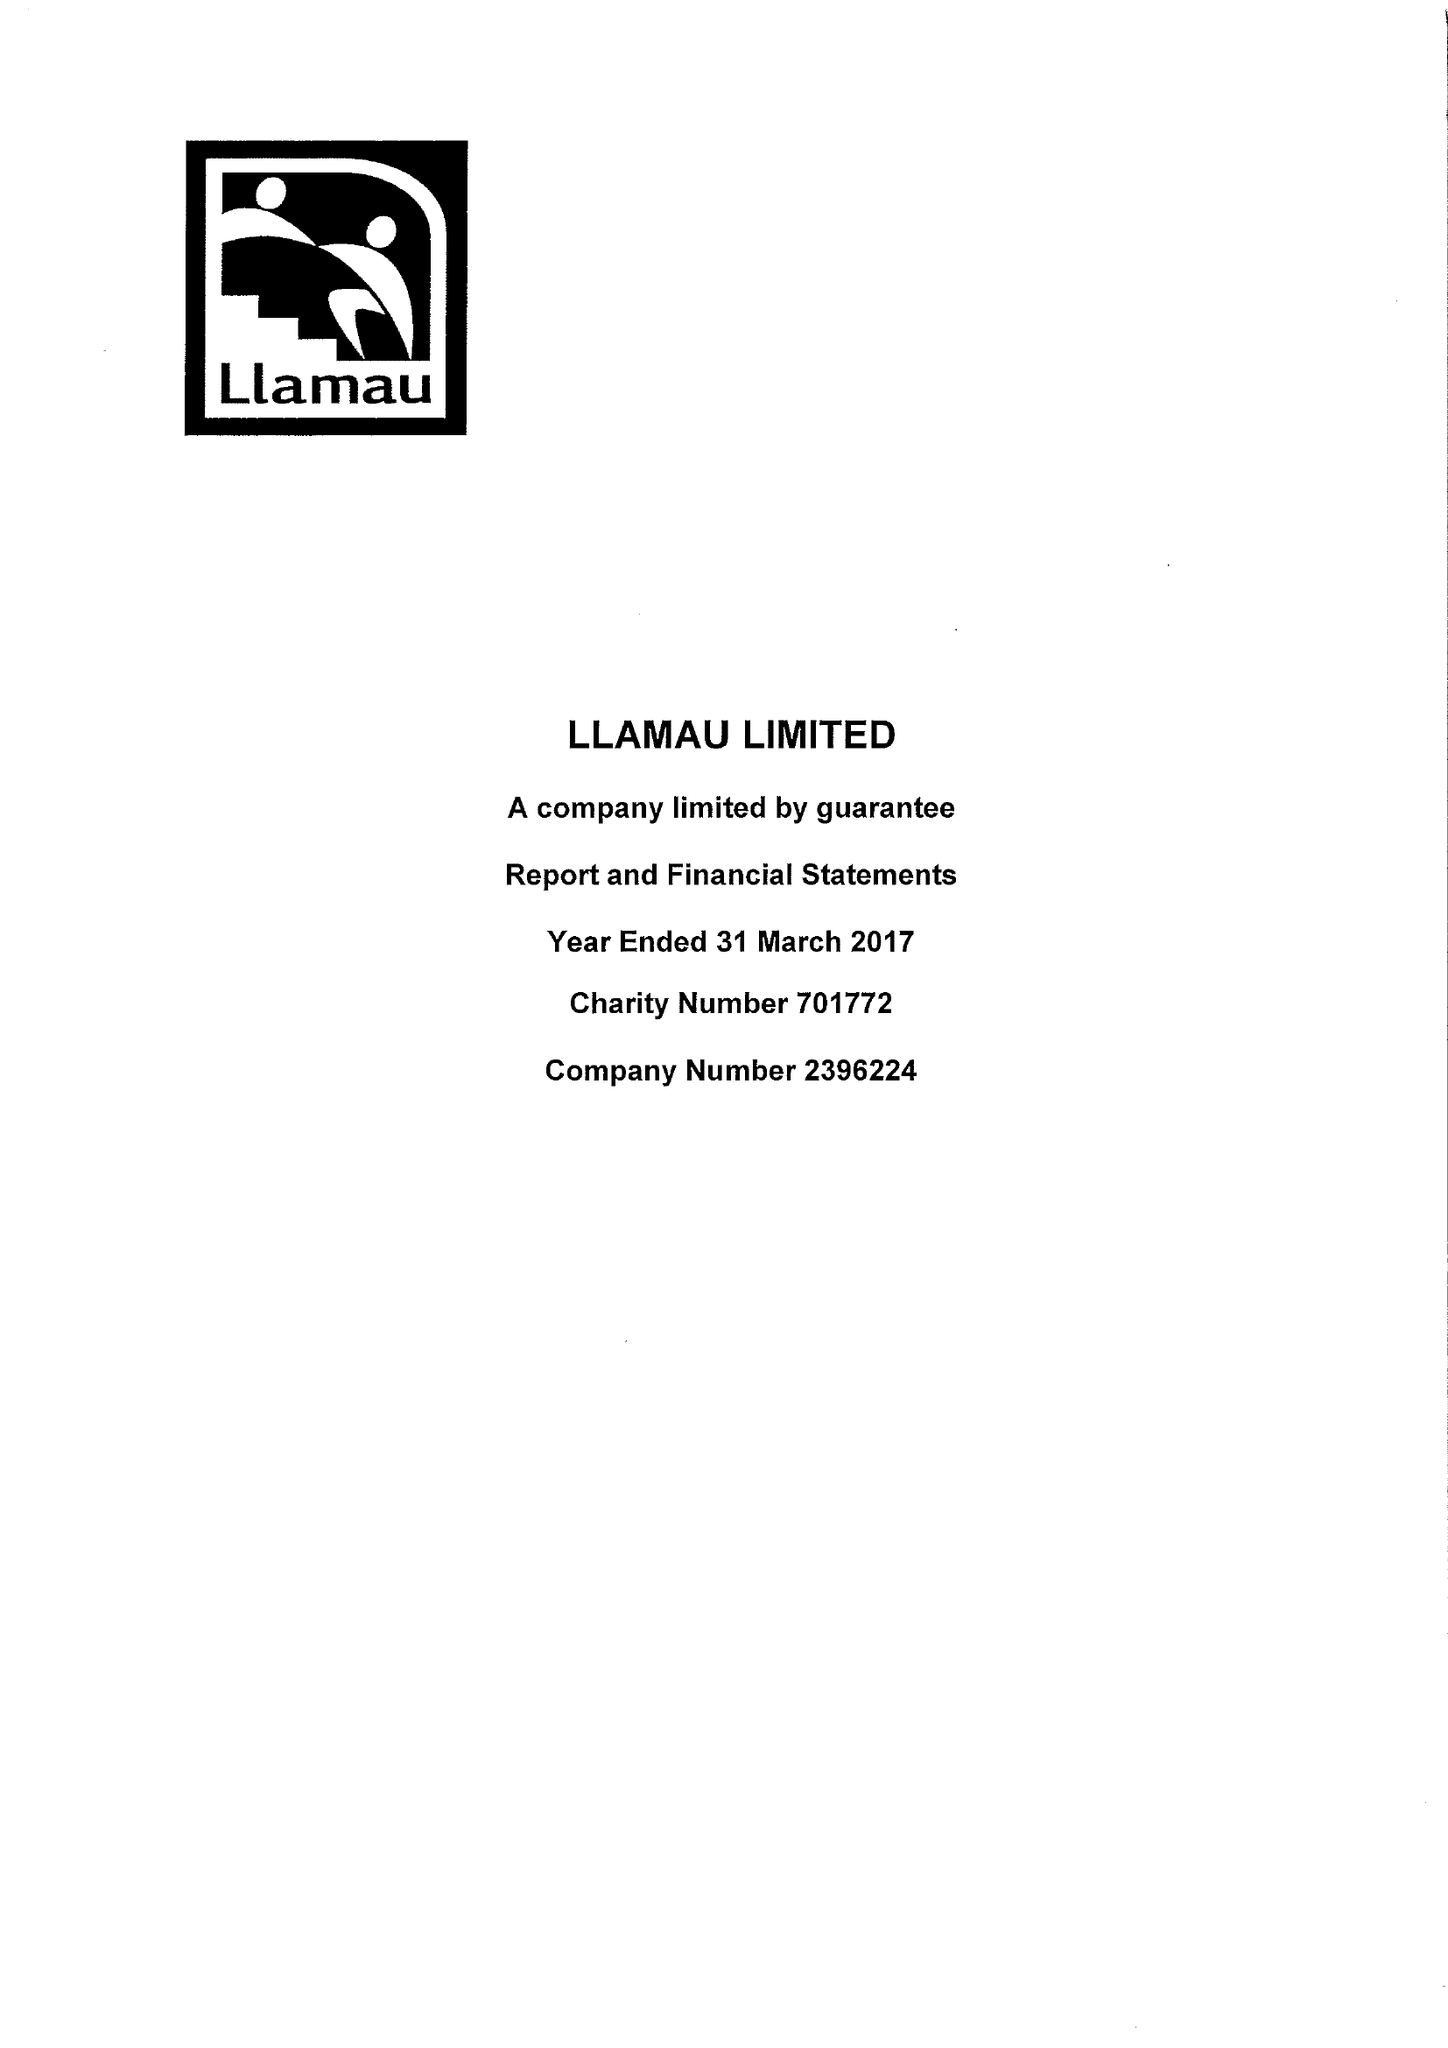What is the value for the charity_number?
Answer the question using a single word or phrase. 701772 